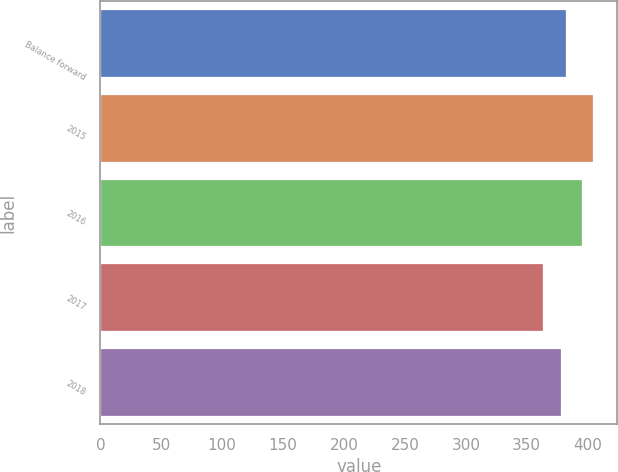Convert chart to OTSL. <chart><loc_0><loc_0><loc_500><loc_500><bar_chart><fcel>Balance forward<fcel>2015<fcel>2016<fcel>2017<fcel>2018<nl><fcel>382.1<fcel>404<fcel>395<fcel>363<fcel>378<nl></chart> 